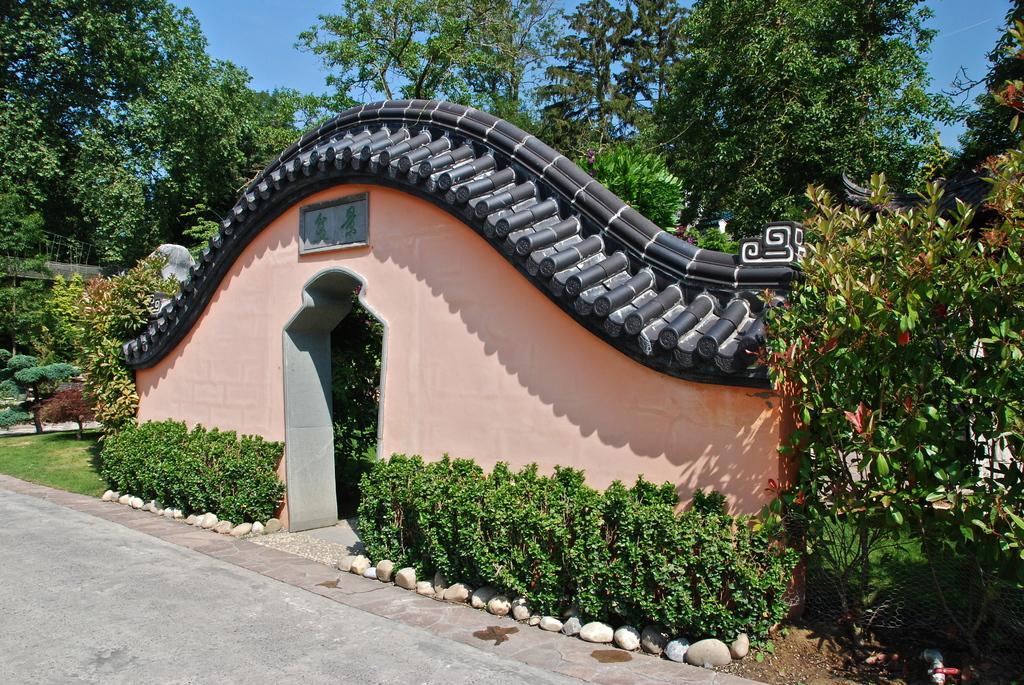Please provide a concise description of this image. In this image there is a pavement and there are plants and an architecture, in the background there are trees and the sky. 